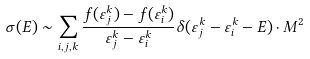<formula> <loc_0><loc_0><loc_500><loc_500>\sigma ( E ) \sim \sum _ { i , j , k } \frac { f ( \varepsilon _ { j } ^ { k } ) - f ( \varepsilon _ { i } ^ { k } ) } { \varepsilon _ { j } ^ { k } - \varepsilon _ { i } ^ { k } } \delta ( \varepsilon _ { j } ^ { k } - \varepsilon _ { i } ^ { k } - E ) \cdot M ^ { 2 }</formula> 